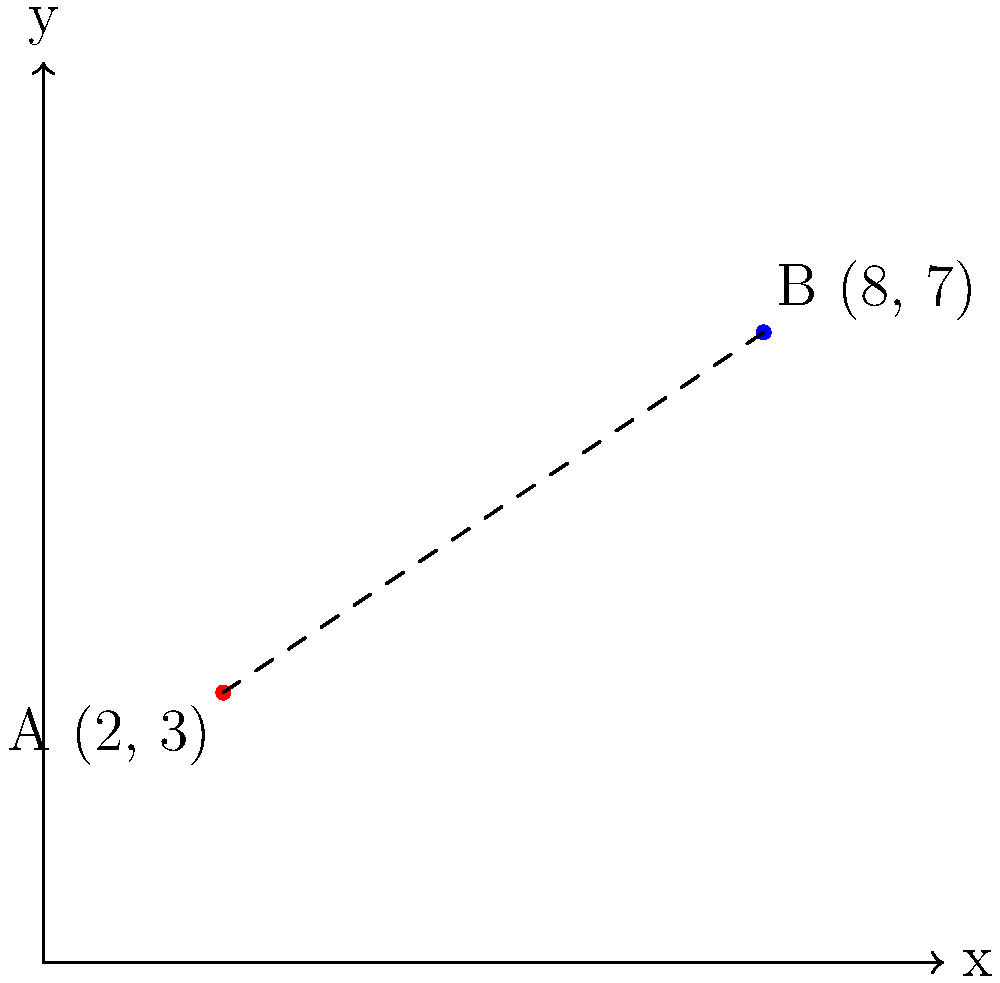As a small business owner, you're planning to open a new branch. Your main store is located at point A (2, 3), and you're considering a new location at point B (8, 7). To estimate travel time for deliveries, you need to calculate the straight-line distance between these two points. Using the distance formula, what is the distance between your current store and the potential new location? Round your answer to two decimal places. Let's solve this step-by-step using the distance formula:

1) The distance formula is:
   $$d = \sqrt{(x_2 - x_1)^2 + (y_2 - y_1)^2}$$

2) We have:
   Point A (current store): $(x_1, y_1) = (2, 3)$
   Point B (new location): $(x_2, y_2) = (8, 7)$

3) Let's substitute these values into the formula:
   $$d = \sqrt{(8 - 2)^2 + (7 - 3)^2}$$

4) Simplify inside the parentheses:
   $$d = \sqrt{6^2 + 4^2}$$

5) Calculate the squares:
   $$d = \sqrt{36 + 16}$$

6) Add inside the square root:
   $$d = \sqrt{52}$$

7) Calculate the square root:
   $$d \approx 7.2111$$

8) Rounding to two decimal places:
   $$d \approx 7.21$$

Therefore, the distance between your current store and the potential new location is approximately 7.21 units (e.g., miles or kilometers, depending on the scale of your map).
Answer: 7.21 units 